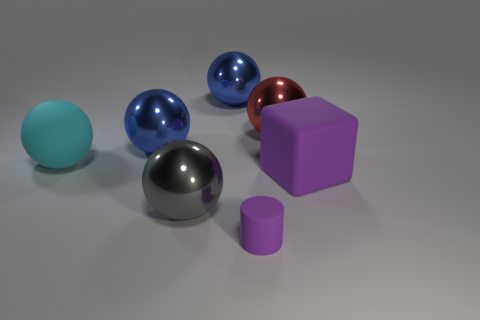Add 3 metal cylinders. How many objects exist? 10 Subtract all red metallic spheres. How many spheres are left? 4 Subtract all blue spheres. How many spheres are left? 3 Subtract 1 balls. How many balls are left? 4 Subtract all large red shiny objects. Subtract all big blue things. How many objects are left? 4 Add 2 blue shiny spheres. How many blue shiny spheres are left? 4 Add 3 rubber objects. How many rubber objects exist? 6 Subtract 0 yellow cylinders. How many objects are left? 7 Subtract all cylinders. How many objects are left? 6 Subtract all gray blocks. Subtract all gray spheres. How many blocks are left? 1 